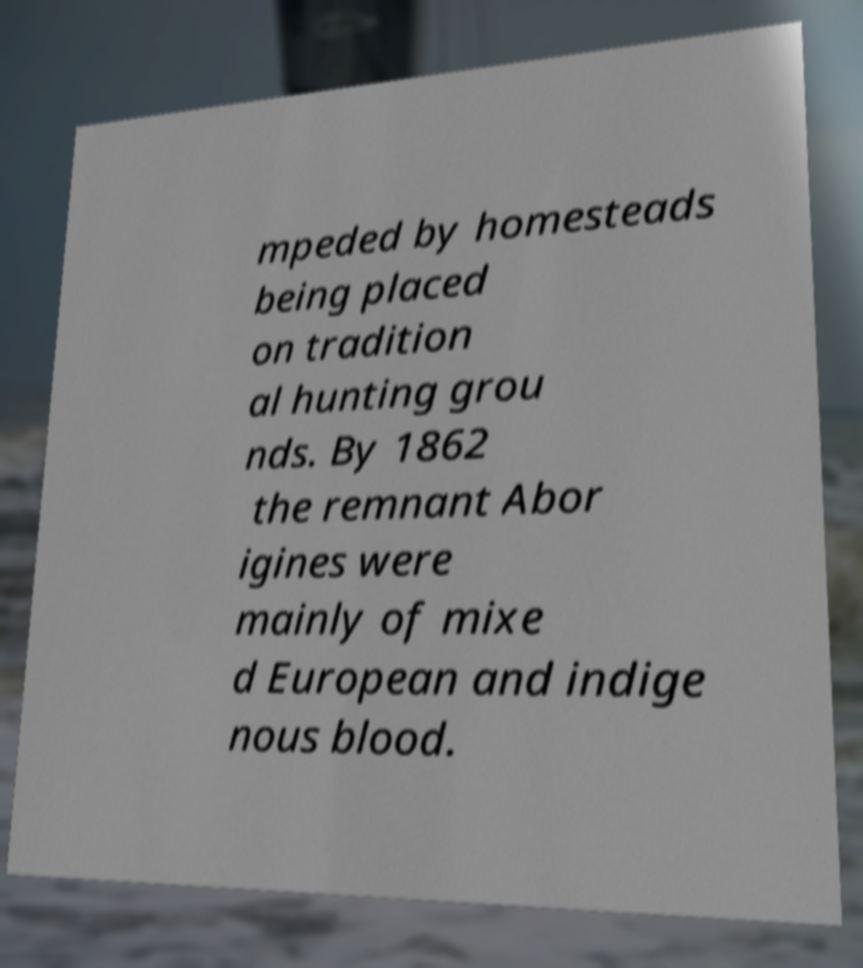Could you assist in decoding the text presented in this image and type it out clearly? mpeded by homesteads being placed on tradition al hunting grou nds. By 1862 the remnant Abor igines were mainly of mixe d European and indige nous blood. 